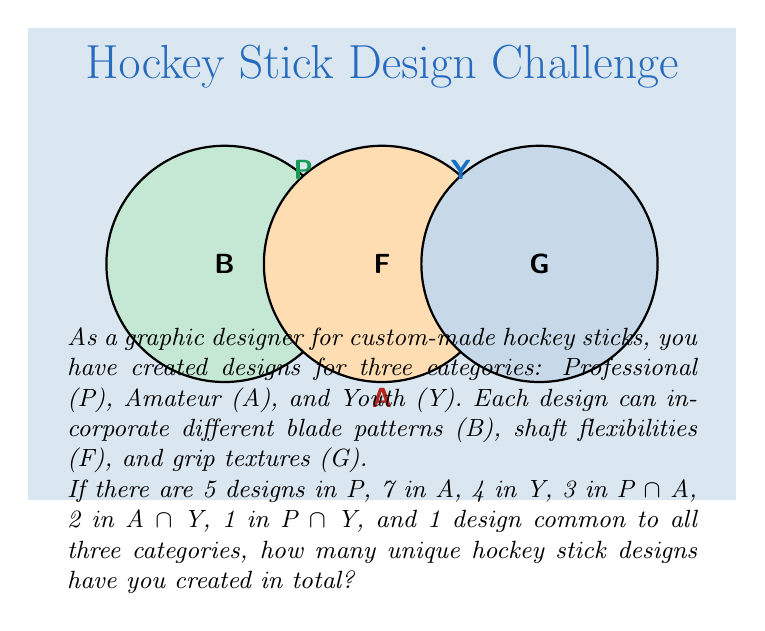Can you answer this question? To solve this problem, we'll use the Inclusion-Exclusion Principle for three sets. Let's follow these steps:

1) First, let's define our sets:
   P: Professional designs
   A: Amateur designs
   Y: Youth designs

2) We're given:
   |P| = 5
   |A| = 7
   |Y| = 4
   |P ∩ A| = 3
   |A ∩ Y| = 2
   |P ∩ Y| = 1
   |P ∩ A ∩ Y| = 1

3) The Inclusion-Exclusion Principle for three sets states:
   |P ∪ A ∪ Y| = |P| + |A| + |Y| - |P ∩ A| - |A ∩ Y| - |P ∩ Y| + |P ∩ A ∩ Y|

4) Let's substitute our values:
   |P ∪ A ∪ Y| = 5 + 7 + 4 - 3 - 2 - 1 + 1

5) Now we can calculate:
   |P ∪ A ∪ Y| = 16 - 6 + 1 = 11

Therefore, the total number of unique hockey stick designs is 11.
Answer: 11 